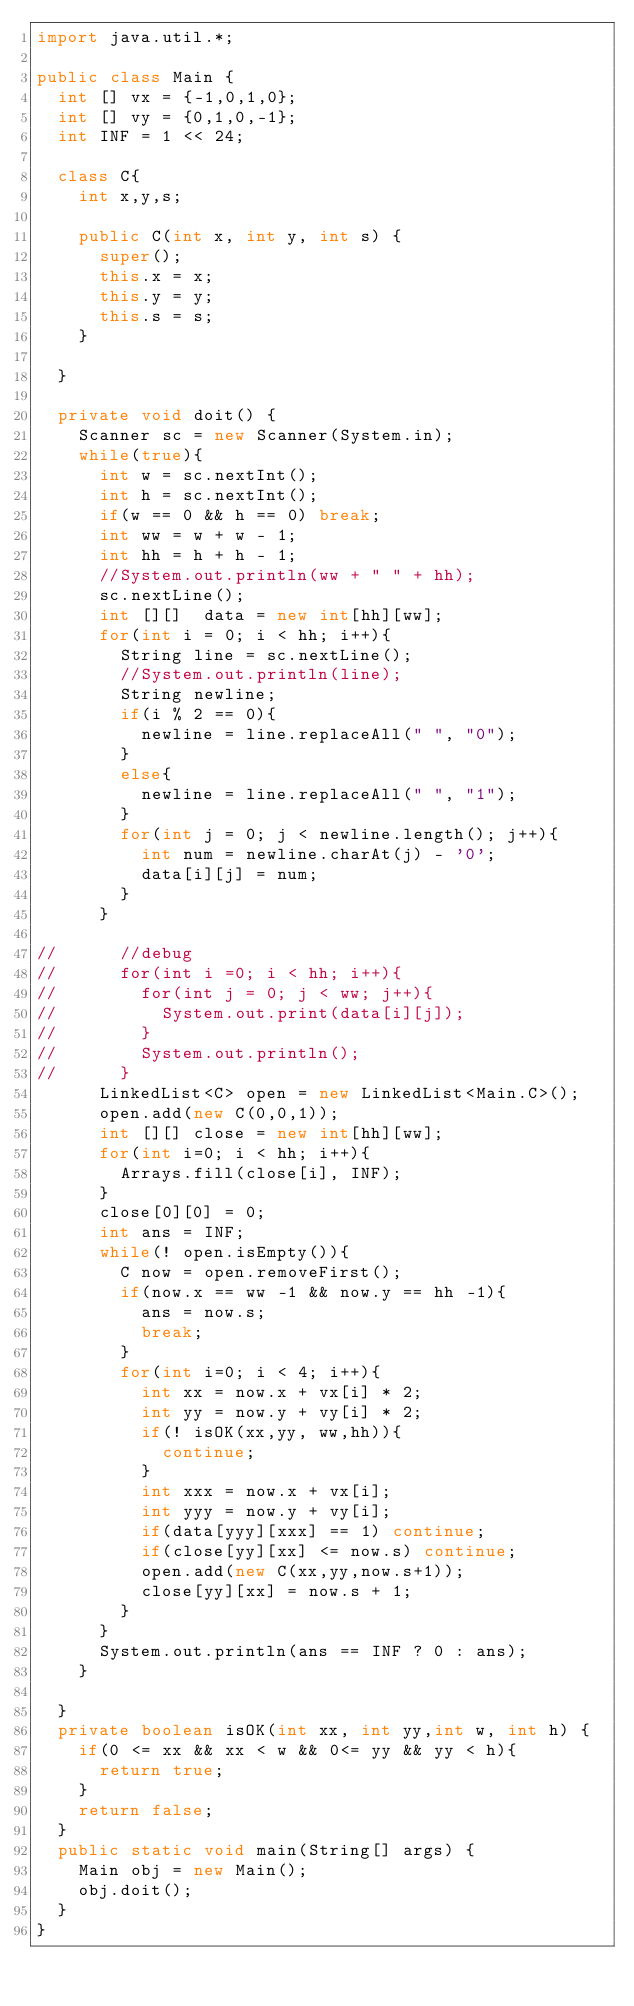<code> <loc_0><loc_0><loc_500><loc_500><_Java_>import java.util.*;

public class Main {
	int [] vx = {-1,0,1,0};
	int [] vy = {0,1,0,-1};
	int INF = 1 << 24;
	
	class C{
		int x,y,s;

		public C(int x, int y, int s) {
			super();
			this.x = x;
			this.y = y;
			this.s = s;
		}
		
	}
	
	private void doit() {
		Scanner sc = new Scanner(System.in);
		while(true){
			int w = sc.nextInt();
			int h = sc.nextInt();
			if(w == 0 && h == 0) break;
			int ww = w + w - 1;
			int hh = h + h - 1;
			//System.out.println(ww + " " + hh);
			sc.nextLine();
			int [][]  data = new int[hh][ww];
			for(int i = 0; i < hh; i++){
				String line = sc.nextLine();
				//System.out.println(line);
				String newline;
				if(i % 2 == 0){
					newline = line.replaceAll(" ", "0");
				}
				else{
					newline = line.replaceAll(" ", "1");
				}
				for(int j = 0; j < newline.length(); j++){
					int num = newline.charAt(j) - '0';
					data[i][j] = num;
				}
			}
			
//			//debug
//			for(int i =0; i < hh; i++){
//				for(int j = 0; j < ww; j++){
//					System.out.print(data[i][j]);
//				}
//				System.out.println();
//			}
			LinkedList<C> open = new LinkedList<Main.C>();
			open.add(new C(0,0,1));
			int [][] close = new int[hh][ww];
			for(int i=0; i < hh; i++){
				Arrays.fill(close[i], INF);
			}
			close[0][0] = 0;
			int ans = INF;
			while(! open.isEmpty()){
				C now = open.removeFirst();
				if(now.x == ww -1 && now.y == hh -1){
					ans = now.s;
					break;
				}
				for(int i=0; i < 4; i++){
					int xx = now.x + vx[i] * 2;
					int yy = now.y + vy[i] * 2;
					if(! isOK(xx,yy, ww,hh)){
						continue;
					}
					int xxx = now.x + vx[i];
					int yyy = now.y + vy[i];
					if(data[yyy][xxx] == 1) continue;
					if(close[yy][xx] <= now.s) continue;
					open.add(new C(xx,yy,now.s+1));
					close[yy][xx] = now.s + 1;
				}
			}
			System.out.println(ans == INF ? 0 : ans);
		}
		
	}
	private boolean isOK(int xx, int yy,int w, int h) {
		if(0 <= xx && xx < w && 0<= yy && yy < h){
			return true;
		}
		return false;
	}
	public static void main(String[] args) {
		Main obj = new Main();
		obj.doit();
	}
}</code> 